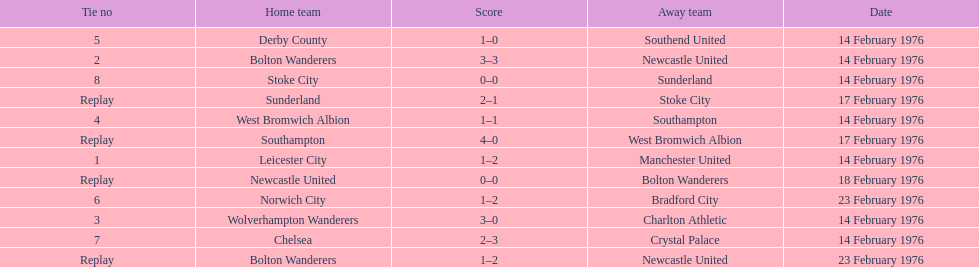How many games were replays? 4. 